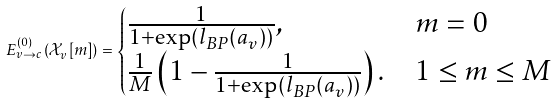<formula> <loc_0><loc_0><loc_500><loc_500>E _ { v \rightarrow c } ^ { ( 0 ) } \left ( \mathcal { X } _ { v } [ m ] \right ) = \begin{cases} \frac { 1 } { 1 + \exp \left ( l _ { B P } \left ( a _ { v } \right ) \right ) } , & m = 0 \\ \frac { 1 } { M } \left ( 1 - \frac { 1 } { 1 + \exp \left ( l _ { B P } \left ( a _ { v } \right ) \right ) } \right ) . & 1 \leq m \leq M \end{cases}</formula> 